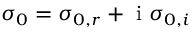<formula> <loc_0><loc_0><loc_500><loc_500>\sigma _ { 0 } = \sigma _ { 0 , r } + i \sigma _ { 0 , i }</formula> 